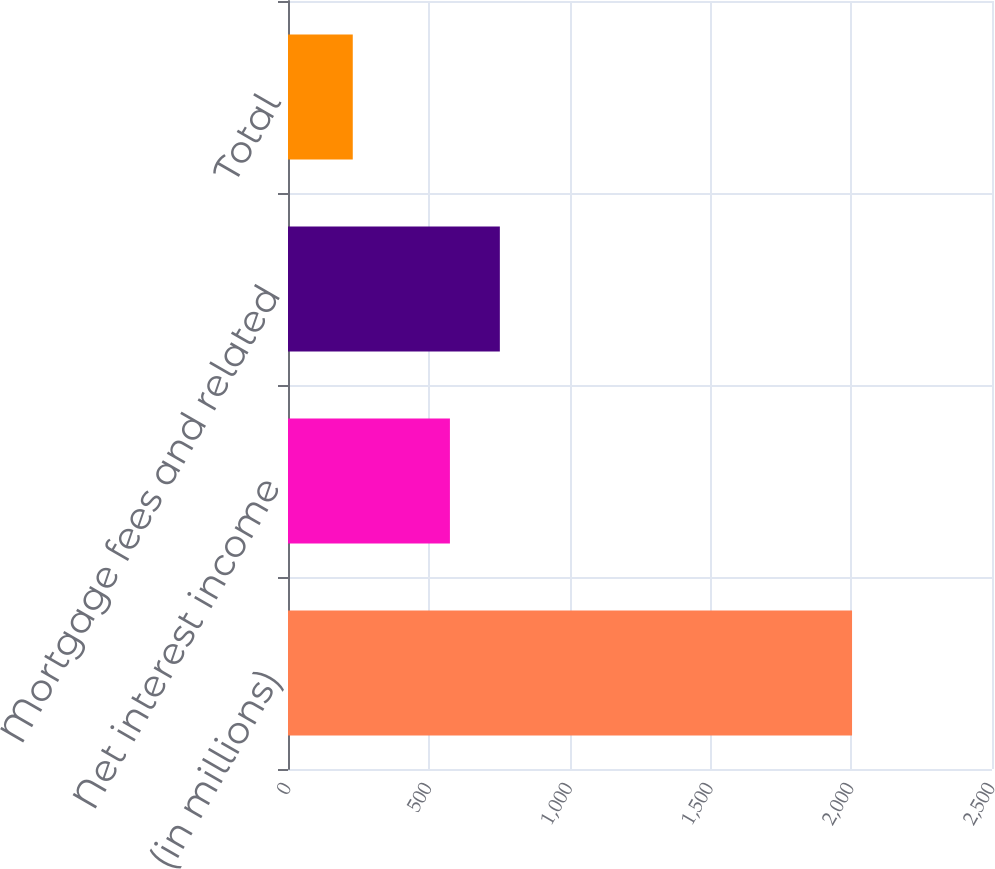<chart> <loc_0><loc_0><loc_500><loc_500><bar_chart><fcel>(in millions)<fcel>Net interest income<fcel>Mortgage fees and related<fcel>Total<nl><fcel>2003<fcel>575<fcel>752.3<fcel>230<nl></chart> 